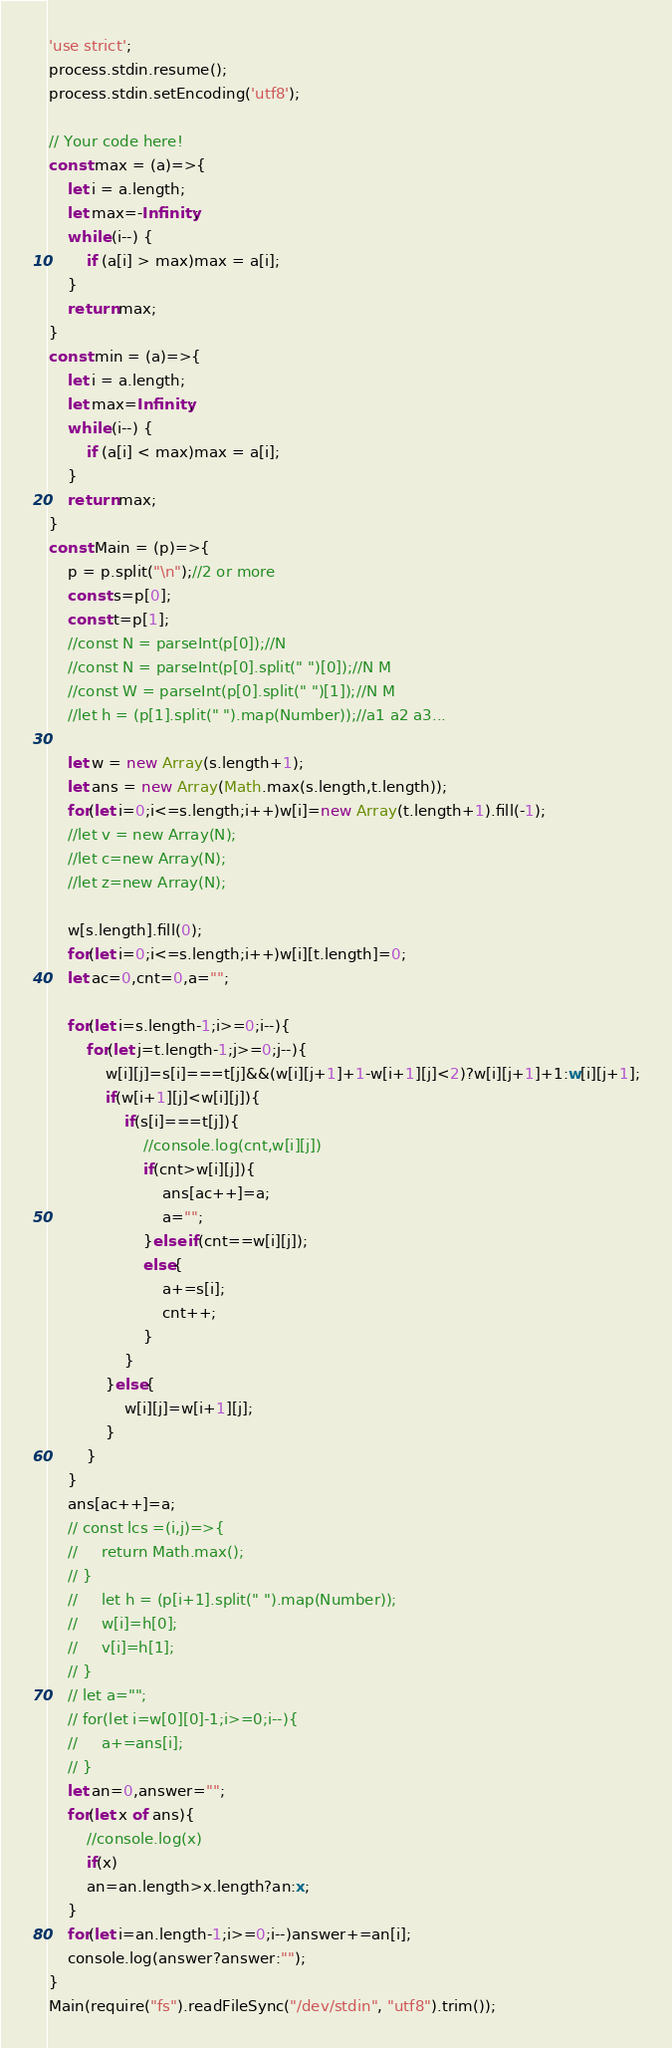<code> <loc_0><loc_0><loc_500><loc_500><_TypeScript_>'use strict';
process.stdin.resume();
process.stdin.setEncoding('utf8');

// Your code here!
const max = (a)=>{
    let i = a.length;
    let max=-Infinity;
    while (i--) {
        if (a[i] > max)max = a[i];
    }
    return max;
}
const min = (a)=>{
    let i = a.length;
    let max=Infinity;
    while (i--) {
        if (a[i] < max)max = a[i];
    }
    return max;
}
const Main = (p)=>{
	p = p.split("\n");//2 or more
	const s=p[0];
	const t=p[1];
	//const N = parseInt(p[0]);//N
    //const N = parseInt(p[0].split(" ")[0]);//N M
	//const W = parseInt(p[0].split(" ")[1]);//N M
	//let h = (p[1].split(" ").map(Number));//a1 a2 a3...

	let w = new Array(s.length+1);
	let ans = new Array(Math.max(s.length,t.length));
	for(let i=0;i<=s.length;i++)w[i]=new Array(t.length+1).fill(-1);
	//let v = new Array(N);
	//let c=new Array(N);
    //let z=new Array(N);

    w[s.length].fill(0);
    for(let i=0;i<=s.length;i++)w[i][t.length]=0;
    let ac=0,cnt=0,a="";
    
    for(let i=s.length-1;i>=0;i--){
        for(let j=t.length-1;j>=0;j--){
            w[i][j]=s[i]===t[j]&&(w[i][j+1]+1-w[i+1][j]<2)?w[i][j+1]+1:w[i][j+1];
            if(w[i+1][j]<w[i][j]){
                if(s[i]===t[j]){
                    //console.log(cnt,w[i][j])
                    if(cnt>w[i][j]){
                        ans[ac++]=a;
                        a="";
                    }else if(cnt==w[i][j]);
                    else{
                        a+=s[i];
                        cnt++;   
                    }
                }
            }else{
                w[i][j]=w[i+1][j];
            }
        }
    }
    ans[ac++]=a;
    // const lcs =(i,j)=>{
    //     return Math.max();
    // }
    //     let h = (p[i+1].split(" ").map(Number));
    //     w[i]=h[0];
    //     v[i]=h[1];
    // }
    // let a="";
    // for(let i=w[0][0]-1;i>=0;i--){
    //     a+=ans[i];
    // }
    let an=0,answer="";
    for(let x of ans){
        //console.log(x)
        if(x)
        an=an.length>x.length?an:x;
    }
    for(let i=an.length-1;i>=0;i--)answer+=an[i];
	console.log(answer?answer:"");
}
Main(require("fs").readFileSync("/dev/stdin", "utf8").trim());
</code> 